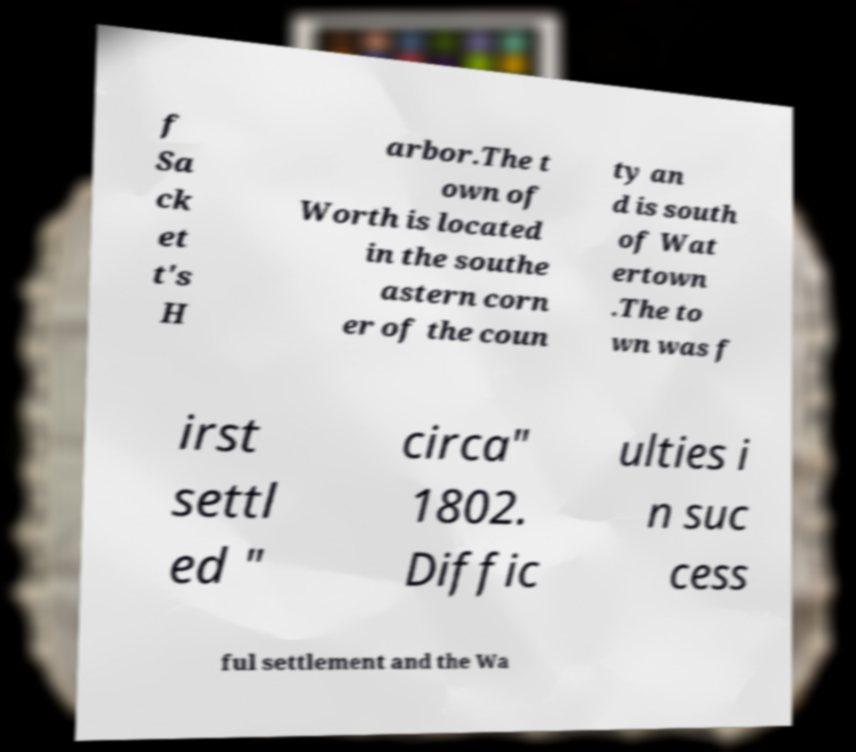Can you accurately transcribe the text from the provided image for me? f Sa ck et t's H arbor.The t own of Worth is located in the southe astern corn er of the coun ty an d is south of Wat ertown .The to wn was f irst settl ed " circa" 1802. Diffic ulties i n suc cess ful settlement and the Wa 